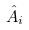Convert formula to latex. <formula><loc_0><loc_0><loc_500><loc_500>\hat { A } _ { i }</formula> 